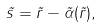<formula> <loc_0><loc_0><loc_500><loc_500>\vec { s } = \vec { r } - \vec { \alpha } ( \vec { r } ) ,</formula> 